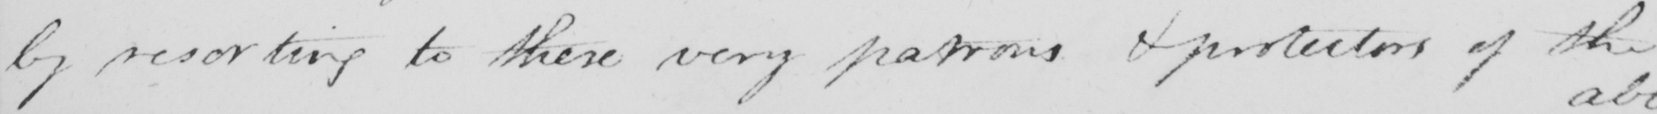Please provide the text content of this handwritten line. by resorting to these very patrons & protectors of the 